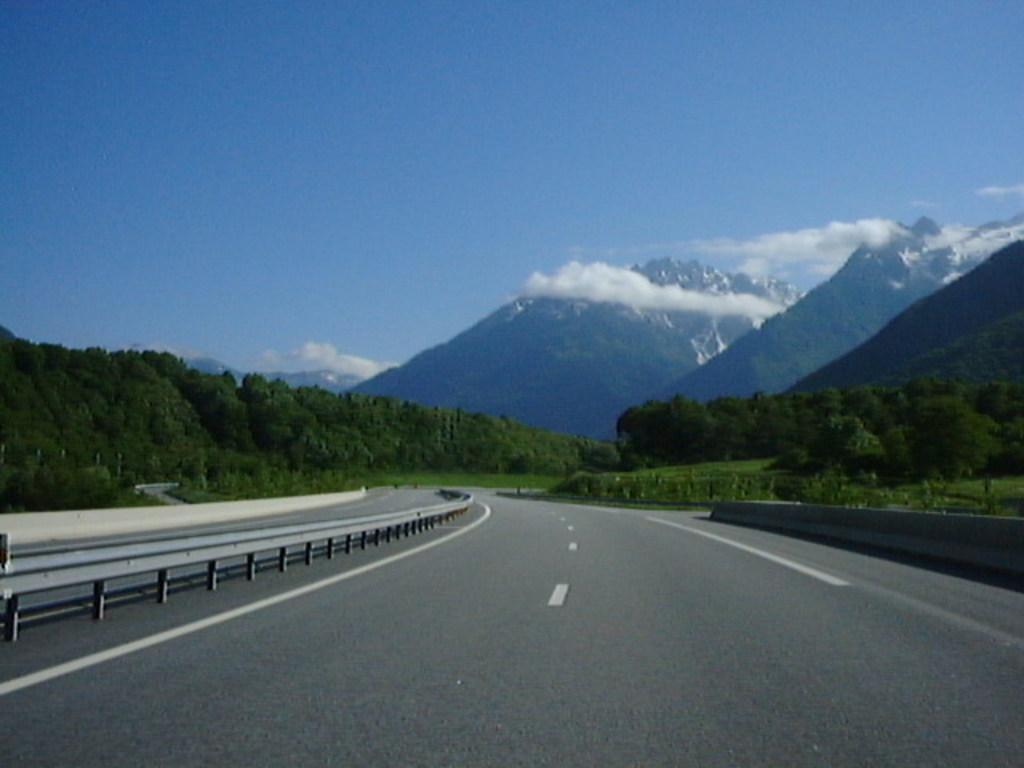Describe this image in one or two sentences. This picture is clicked in the outskirts. At the bottom of the picture, we see the road. Beside that, we see a railing. There are trees and hills in the background. At the top of the picture, we see the sky, which is blue in color. 